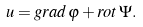Convert formula to latex. <formula><loc_0><loc_0><loc_500><loc_500>u = g r a d \, \varphi + r o t \, \Psi .</formula> 